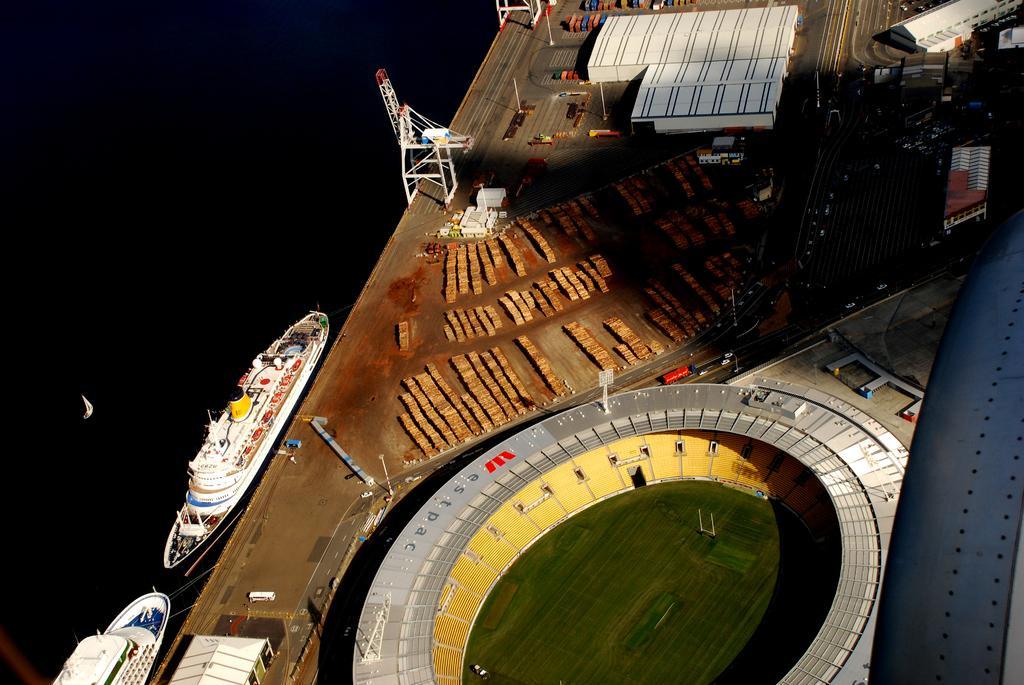Can you describe this image briefly? In this image I can see the stadium, few sheds, poles, vehicles and few objects. I can see few ships. 